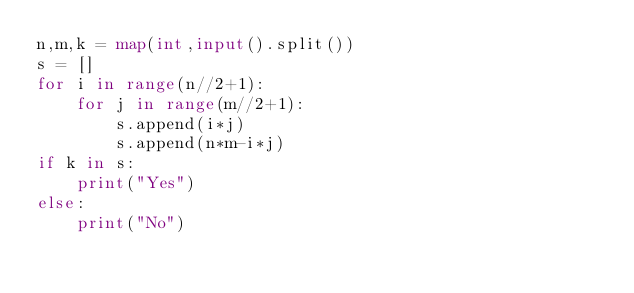<code> <loc_0><loc_0><loc_500><loc_500><_Python_>n,m,k = map(int,input().split())
s = []
for i in range(n//2+1):
    for j in range(m//2+1):
        s.append(i*j)
        s.append(n*m-i*j)
if k in s:
    print("Yes")
else:
    print("No")</code> 